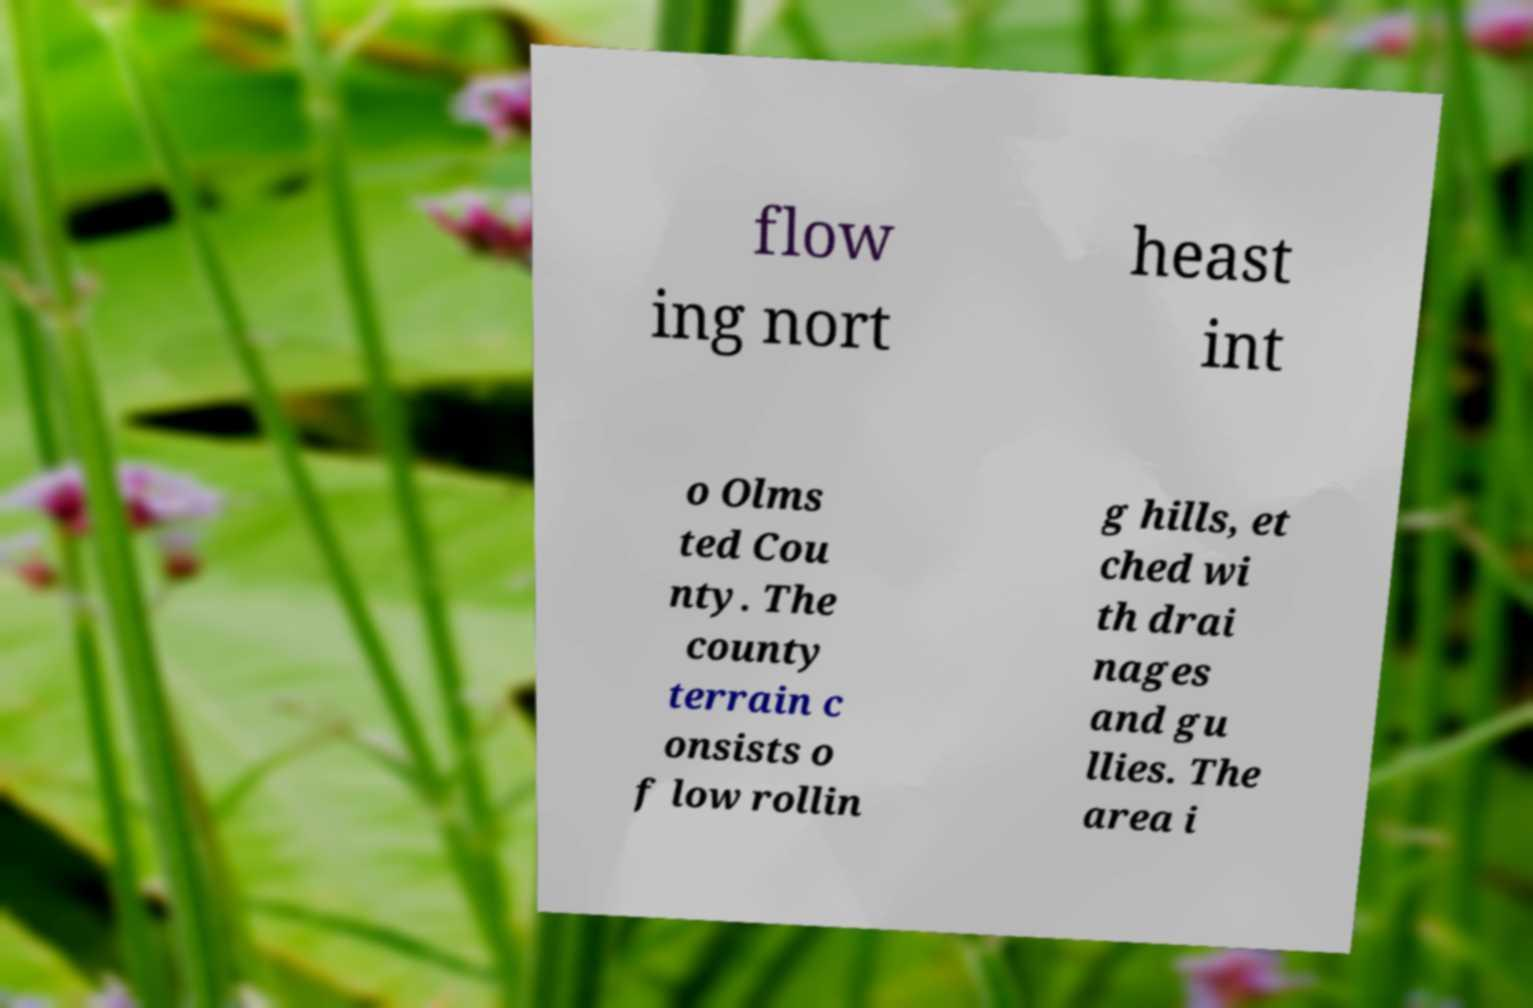Please read and relay the text visible in this image. What does it say? flow ing nort heast int o Olms ted Cou nty. The county terrain c onsists o f low rollin g hills, et ched wi th drai nages and gu llies. The area i 